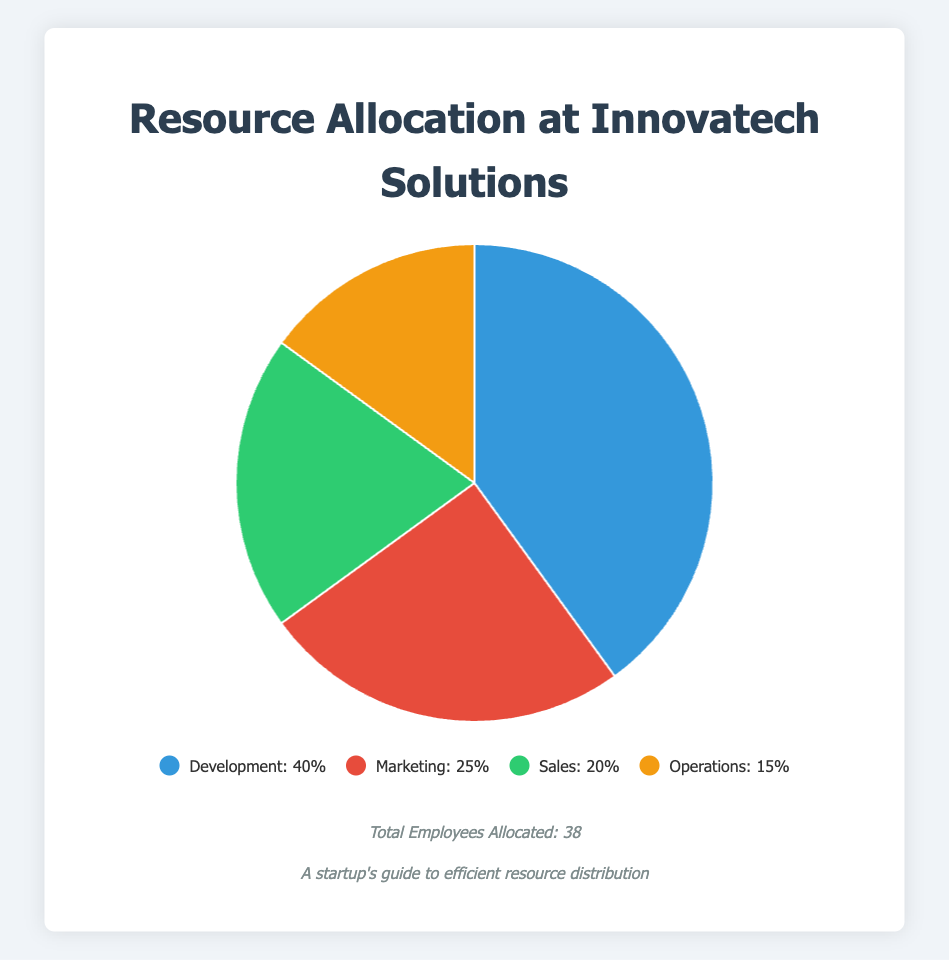What's the highest percentage allocated to any department? By looking at the pie chart, Development has the largest segment, signifying the highest allocation. The legend confirms this with Development having 40%.
Answer: 40% Comparatively, which department has the least allocation and what is that percentage? From the pie chart, the smallest segment represents Operations. The legend states Operations has 15%.
Answer: Operations, 15% Sum the budget percentages of Marketing and Sales. Marketing is 25% and Sales is 20%. Adding these gives 25% + 20% = 45%.
Answer: 45% What is the difference in percentage allocation between Development and Operations? Development has 40% allocation, and Operations has 15%. The difference is 40% - 15% = 25%.
Answer: 25% If we combine the allocations for Sales and Operations, what fraction of the total budget does it represent? Sales has 20% and Operations has 15%. Combined, it's 20% + 15% = 35%. This is 35% of the total budget.
Answer: 35% Which department has a larger allocation, Marketing or Sales, and by how much? Marketing has 25% and Sales has 20%. Subtracting, 25% - 20% = 5%.
Answer: Marketing, 5% How many departments have more than 20% allocation in the budget? From the legend or the pie chart, both Development (40%) and Marketing (25%) have more than 20%, so there are 2 departments.
Answer: 2 Considering employees allocated, which department has the highest number, and how many employees are allocated there? The list shows Development has the highest number of employees at 15.
Answer: Development, 15 What is the average budget allocation percentage across all departments? The sum of percentages is 40% + 25% + 20% + 15% = 100%. Dividing by 4 departments gives 100% / 4 = 25%.
Answer: 25% What are the visual representations for Sales and Operations in terms of colors used? The pie chart uses green for Sales and orange for Operations as seen in the legend.
Answer: green, orange 